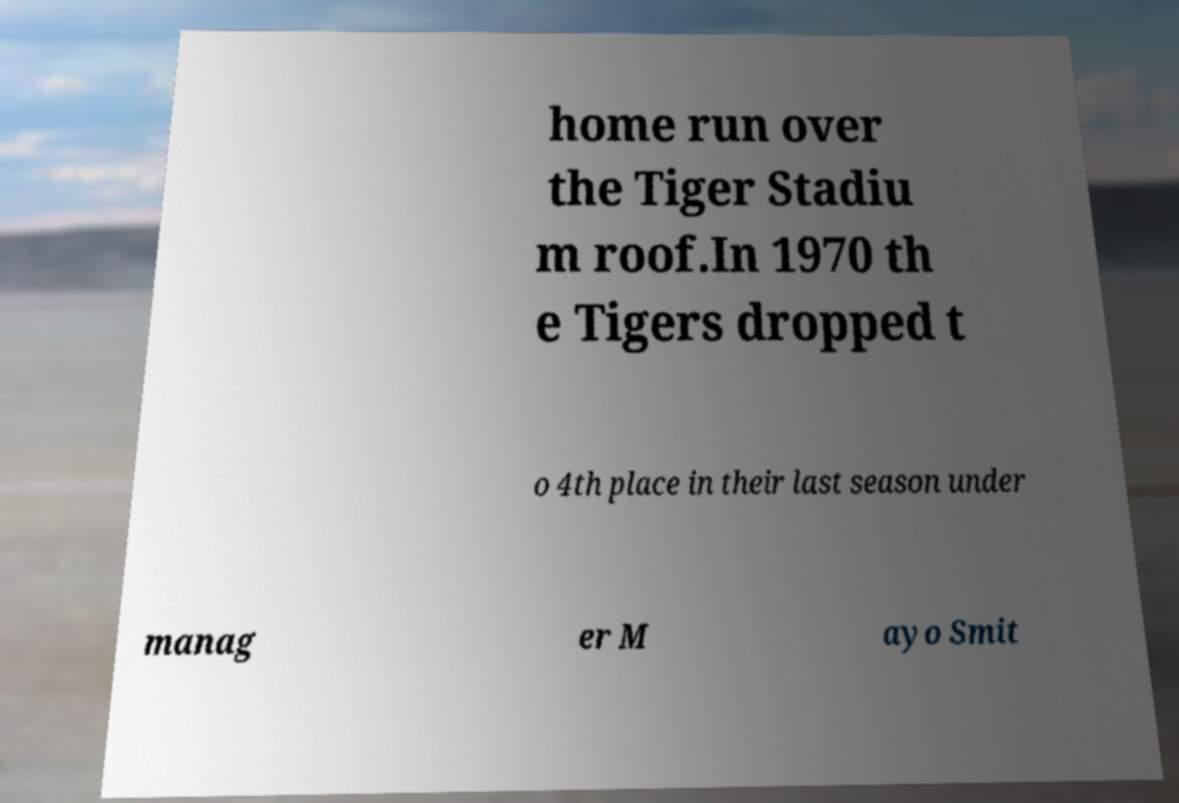Could you assist in decoding the text presented in this image and type it out clearly? home run over the Tiger Stadiu m roof.In 1970 th e Tigers dropped t o 4th place in their last season under manag er M ayo Smit 